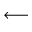Convert formula to latex. <formula><loc_0><loc_0><loc_500><loc_500>\longleftarrow</formula> 